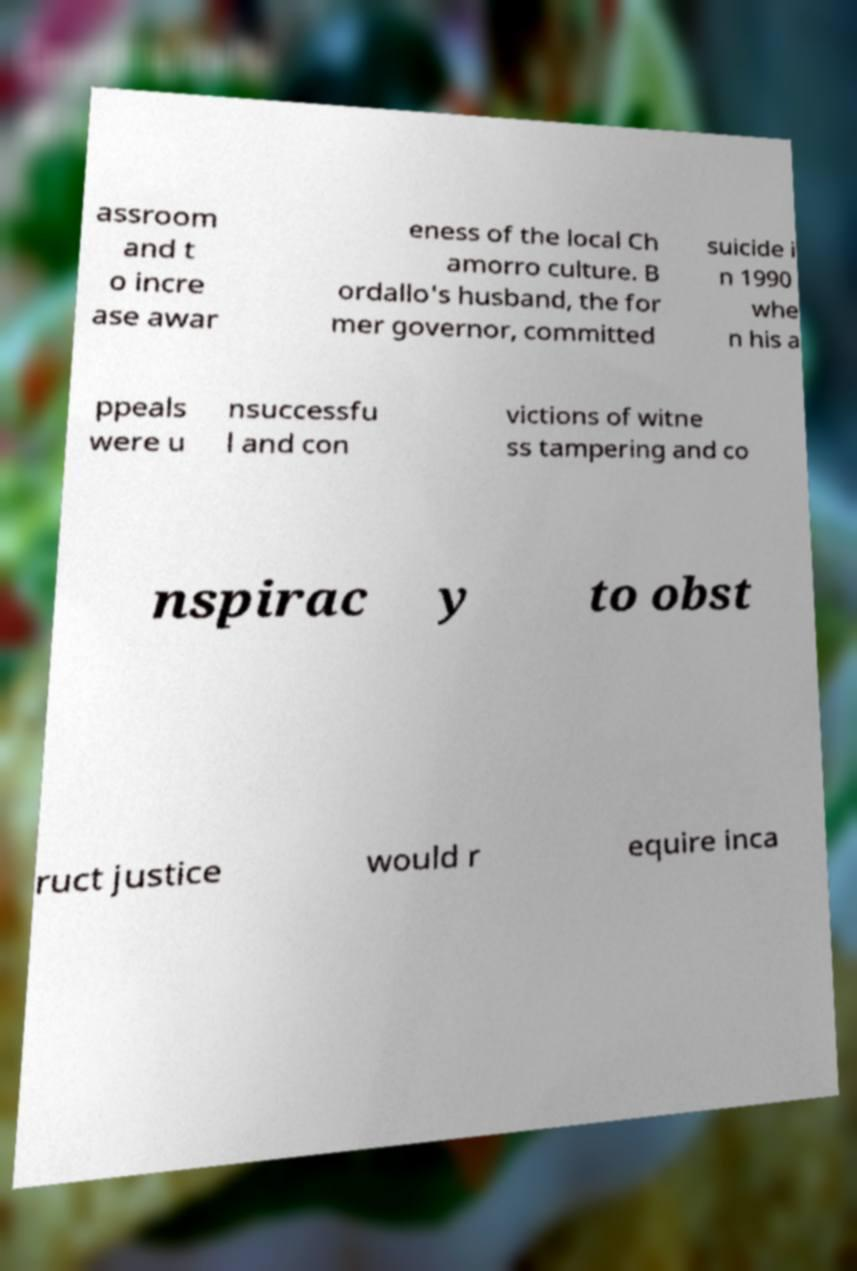What messages or text are displayed in this image? I need them in a readable, typed format. assroom and t o incre ase awar eness of the local Ch amorro culture. B ordallo's husband, the for mer governor, committed suicide i n 1990 whe n his a ppeals were u nsuccessfu l and con victions of witne ss tampering and co nspirac y to obst ruct justice would r equire inca 